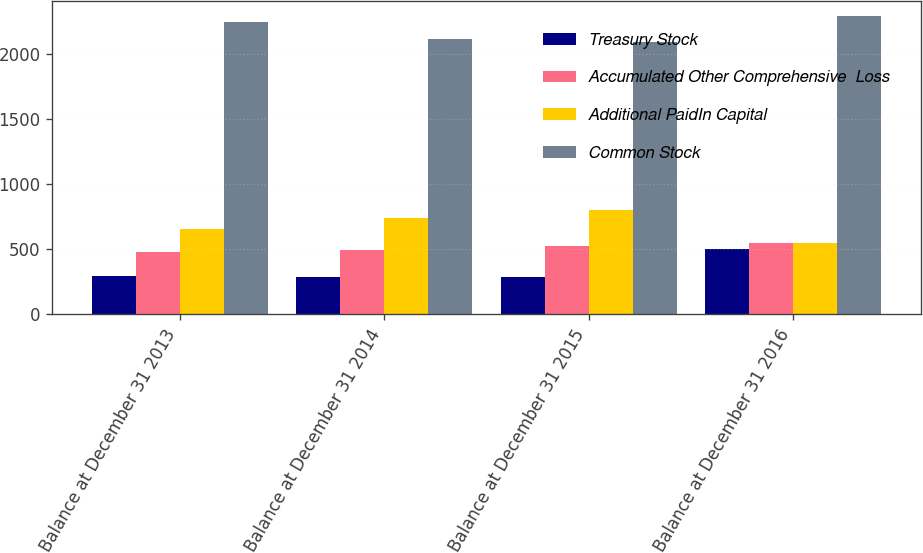<chart> <loc_0><loc_0><loc_500><loc_500><stacked_bar_chart><ecel><fcel>Balance at December 31 2013<fcel>Balance at December 31 2014<fcel>Balance at December 31 2015<fcel>Balance at December 31 2016<nl><fcel>Treasury Stock<fcel>297.5<fcel>288.7<fcel>287.5<fcel>504.8<nl><fcel>Accumulated Other Comprehensive  Loss<fcel>477.2<fcel>493.1<fcel>523.1<fcel>545.3<nl><fcel>Additional PaidIn Capital<fcel>654.3<fcel>739<fcel>801.4<fcel>545.3<nl><fcel>Common Stock<fcel>2242.1<fcel>2111.2<fcel>2090.9<fcel>2289.9<nl></chart> 